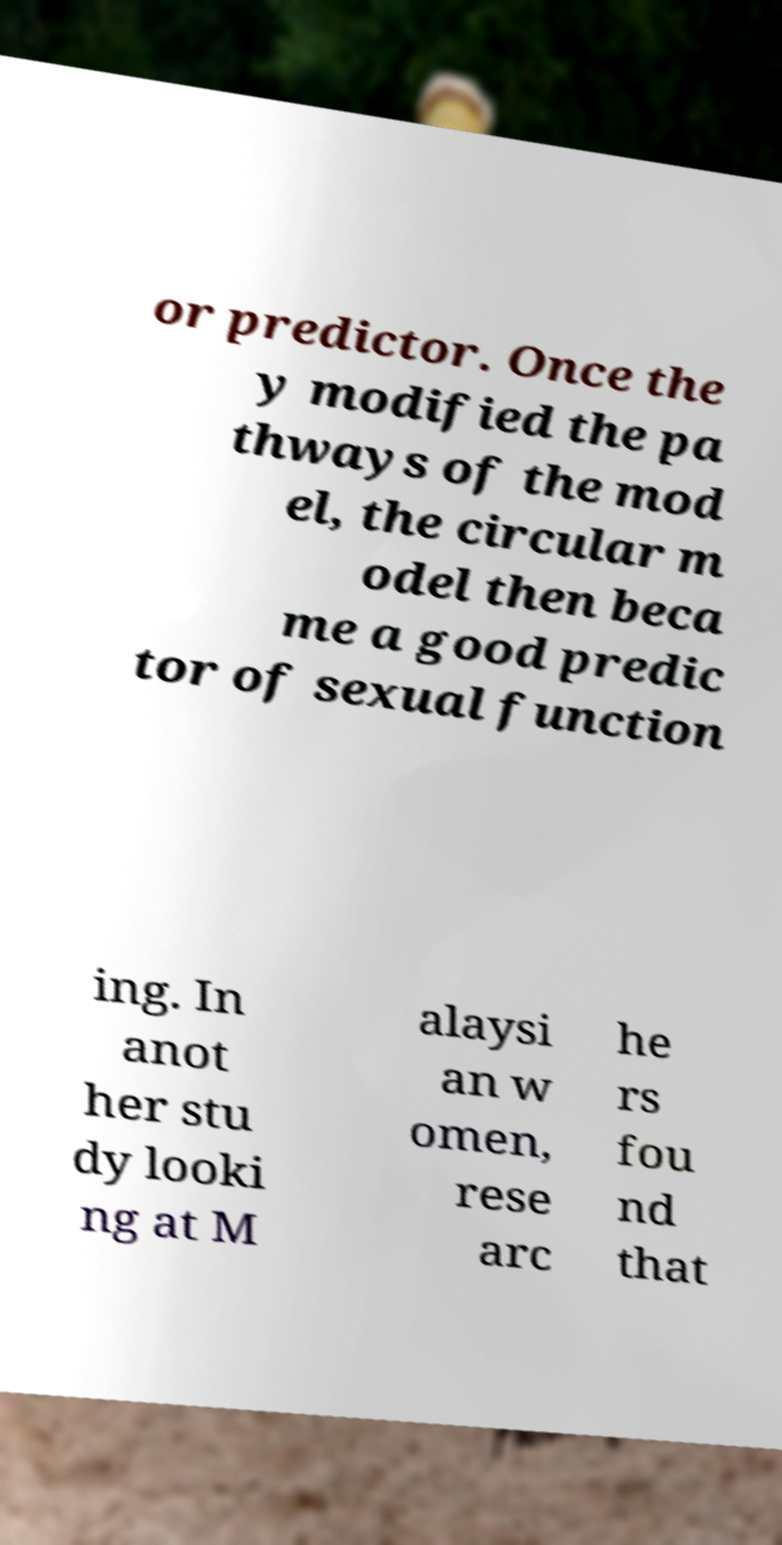Could you extract and type out the text from this image? or predictor. Once the y modified the pa thways of the mod el, the circular m odel then beca me a good predic tor of sexual function ing. In anot her stu dy looki ng at M alaysi an w omen, rese arc he rs fou nd that 